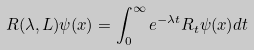Convert formula to latex. <formula><loc_0><loc_0><loc_500><loc_500>R ( \lambda , L ) \psi ( x ) = \int _ { 0 } ^ { \infty } e ^ { - \lambda t } R _ { t } \psi ( x ) d t</formula> 